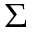Convert formula to latex. <formula><loc_0><loc_0><loc_500><loc_500>\Sigma</formula> 